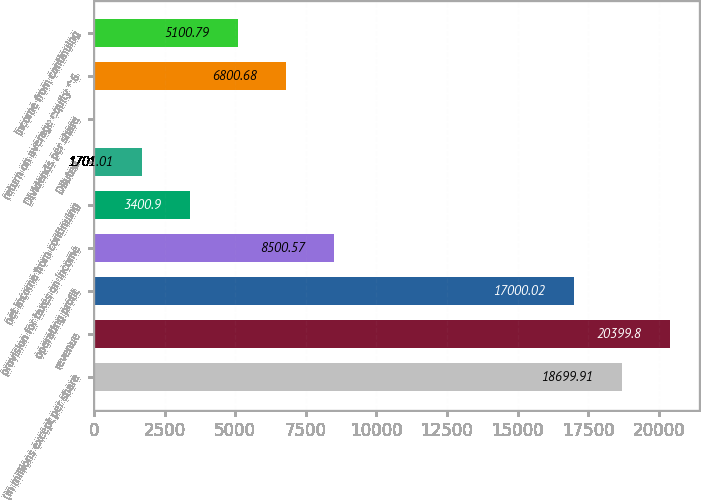Convert chart to OTSL. <chart><loc_0><loc_0><loc_500><loc_500><bar_chart><fcel>(in millions except per share<fcel>revenue<fcel>operating profit<fcel>provision for taxes on income<fcel>net income from continuing<fcel>Diluted<fcel>Dividends per share<fcel>return on average equity ^6<fcel>income from continuing<nl><fcel>18699.9<fcel>20399.8<fcel>17000<fcel>8500.57<fcel>3400.9<fcel>1701.01<fcel>1.12<fcel>6800.68<fcel>5100.79<nl></chart> 